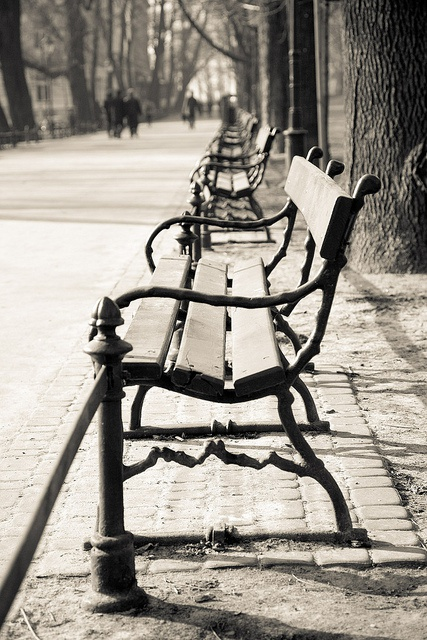Describe the objects in this image and their specific colors. I can see bench in black, lightgray, and gray tones, bench in black, gray, lightgray, and darkgray tones, bench in black, gray, and darkgray tones, people in black and gray tones, and people in black and gray tones in this image. 